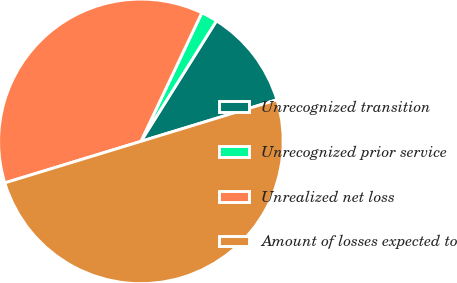<chart> <loc_0><loc_0><loc_500><loc_500><pie_chart><fcel>Unrecognized transition<fcel>Unrecognized prior service<fcel>Unrealized net loss<fcel>Amount of losses expected to<nl><fcel>11.37%<fcel>1.87%<fcel>36.75%<fcel>50.0%<nl></chart> 